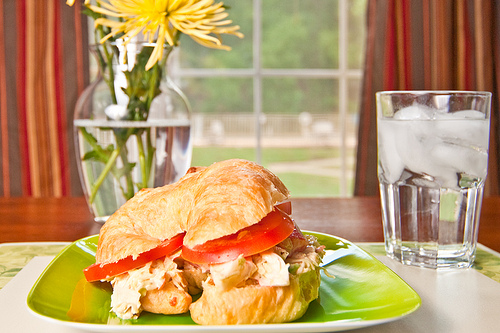Is the water in a bottle? No, the water is not in a bottle; it is in a glass with ice cubes. 